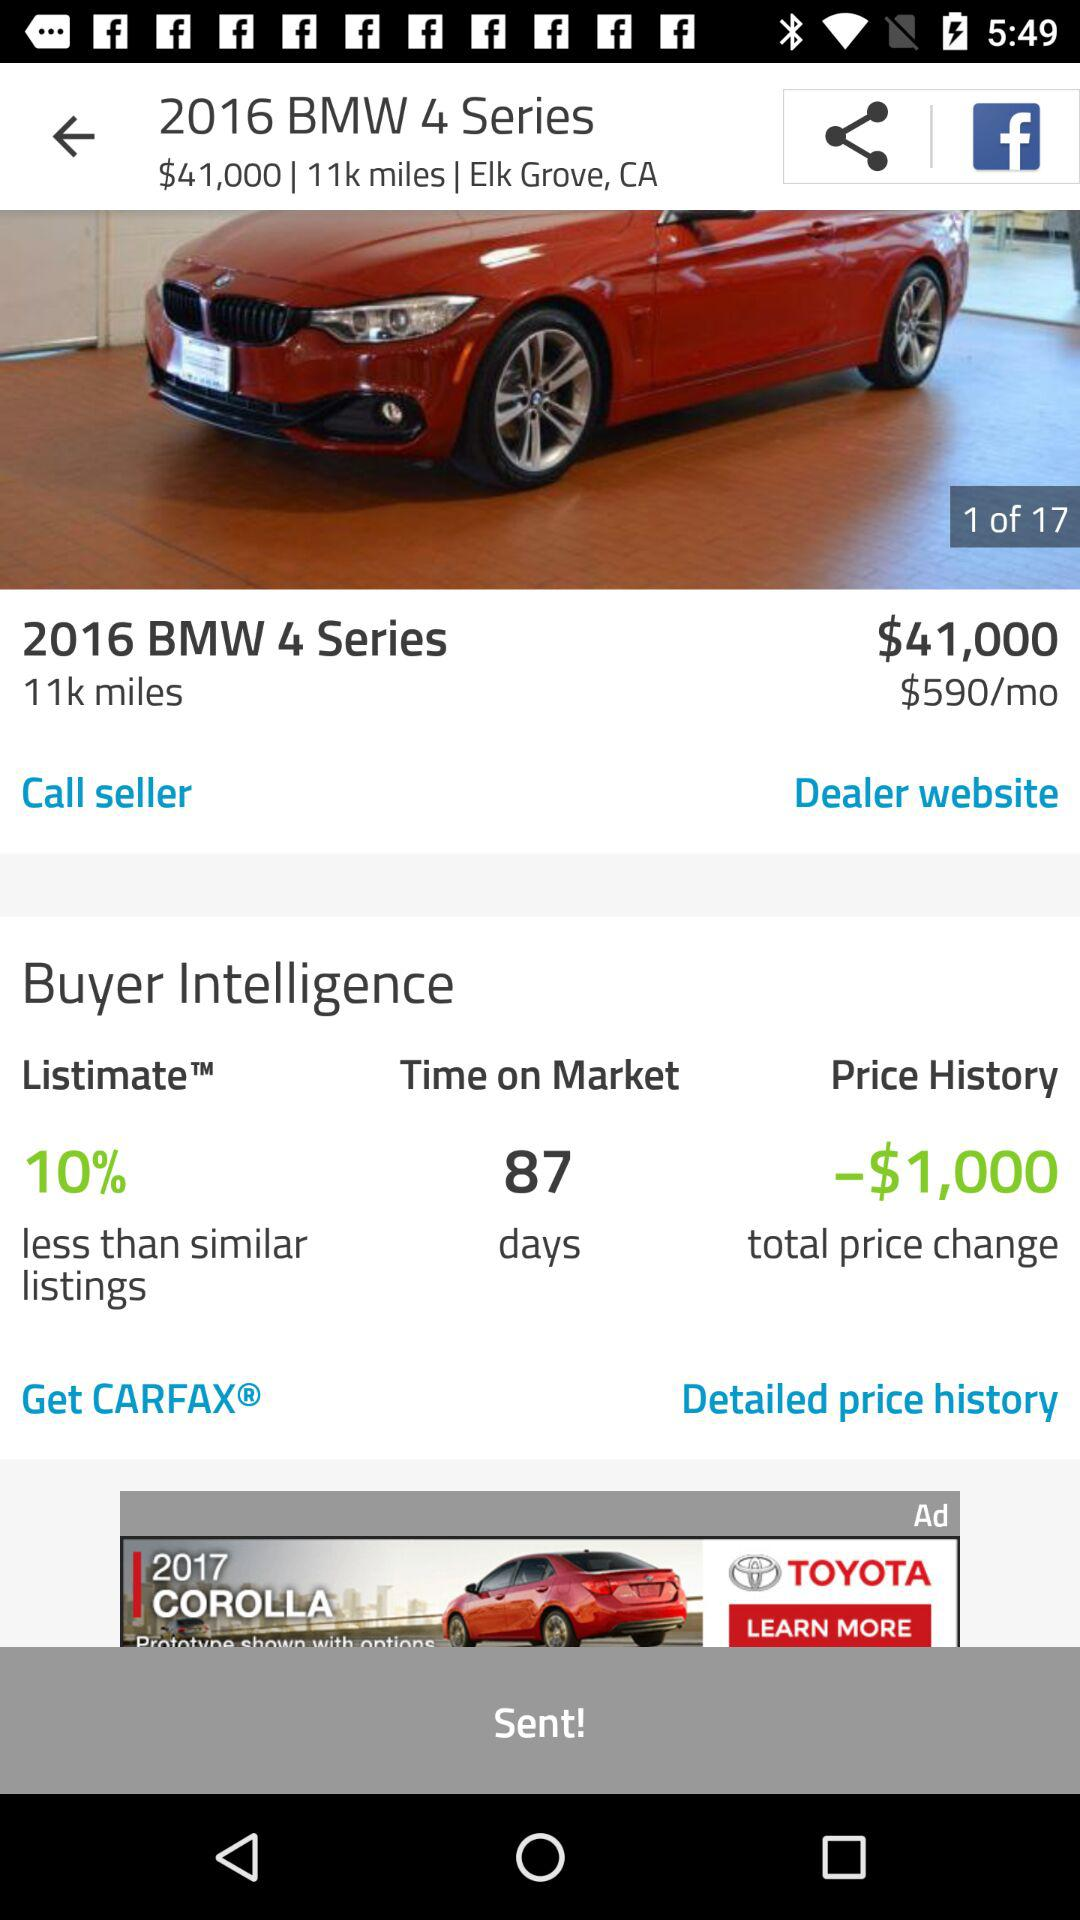How many pictures are available? There are 17 pictures available. 